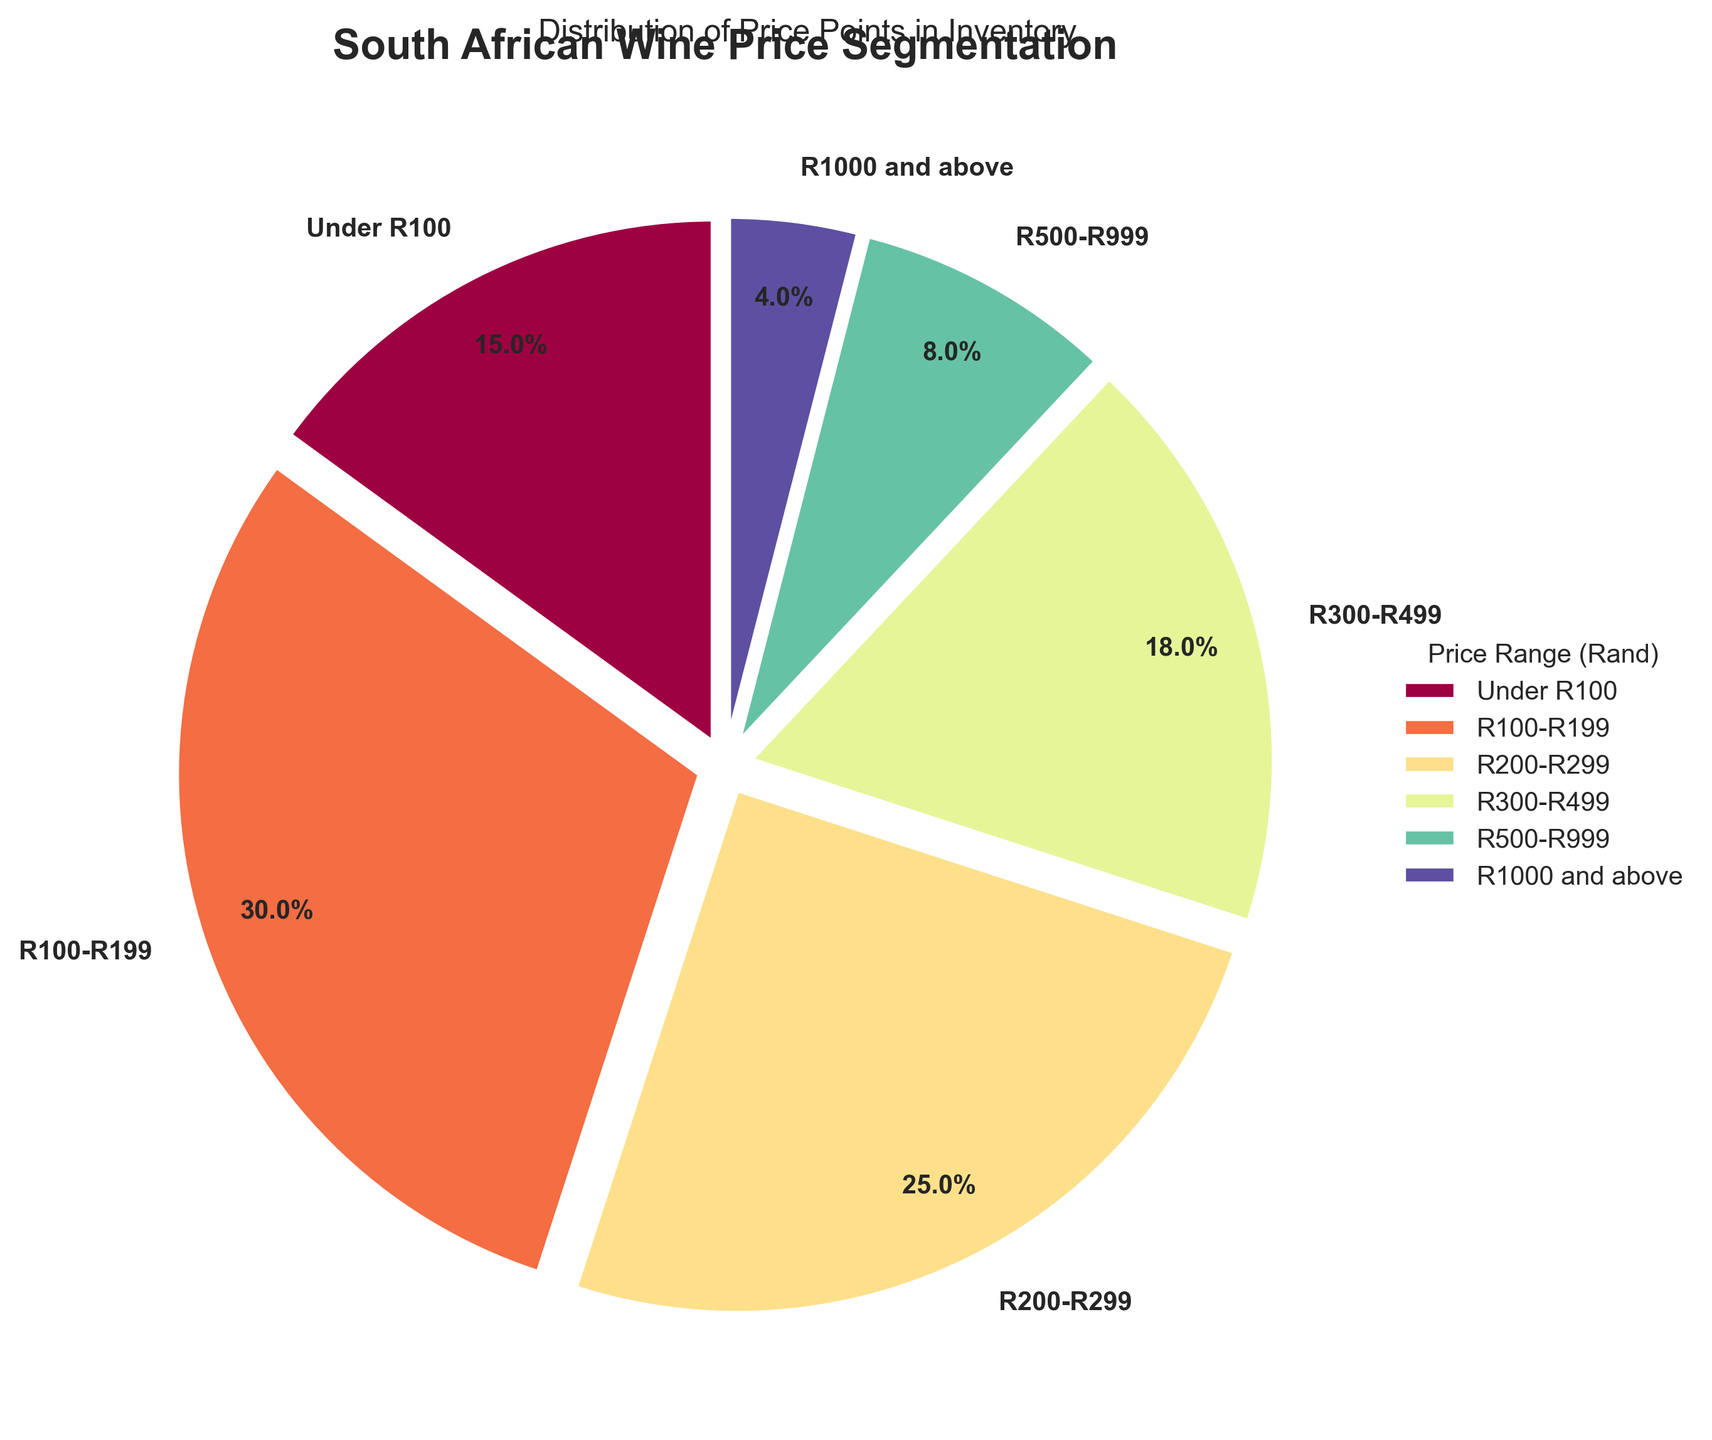What percentage of wines are priced under R100? The figure shows a segment labeled as "Under R100" with a percentage indicated on the pie chart. Locate this segment and read the percentage value.
Answer: 15% What is the combined percentage of wines priced between R200 and R499? Identify the segments labeled "R200-R299" and "R300-R499" on the pie chart. Sum the percentages of these two segments.
Answer: 43% Which price range has the highest percentage of wines in the inventory? Look for the segment with the largest area or the highest percentage value labeled on the pie chart.
Answer: R100-R199 How does the percentage of wines priced R300-R499 compare to the percentage of wines priced R500-R999? Find the segments labeled "R300-R499" and "R500-R999" on the pie chart. Compare their percentage values.
Answer: 18% is greater than 8% What is the least represented price range in the inventory? Identify the segment with the smallest area or the lowest percentage value labeled on the pie chart.
Answer: R1000 and above Are there more wines priced below R200 or between R200 and R499? Sum the percentages of the "Under R100" and "R100-R199" price ranges to compare with the combined percentage of "R200-R299" and "R300-R499".
Answer: More below R200 What is the combined percentage of wines priced either under R100 or R1000 and above? Identify the segments "Under R100" and "R1000 and above". Sum their percentage values.
Answer: 19% Which price range has close to a quarter of the inventory? Look for the segment with a percentage value close to 25%.
Answer: R200-R299 How do the percentages of wines priced R500-R999 and R1000 and above together compare to the percentage of wines priced R300-R499? Sum the percentages of "R500-R999" and "R1000 and above", then compare that sum to the percentage of "R300-R499".
Answer: 12% is less than 18% Between which price ranges is the largest relative percentage difference observed? Calculate the percentage differences between each pair of consecutive price ranges and identify the pair with the largest difference.
Answer: R100-R199 and Under R100 